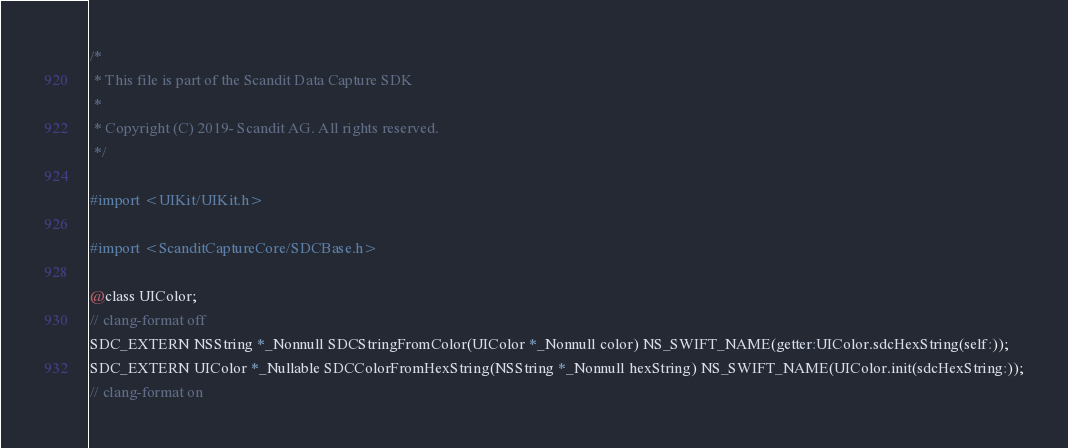<code> <loc_0><loc_0><loc_500><loc_500><_C_>/*
 * This file is part of the Scandit Data Capture SDK
 *
 * Copyright (C) 2019- Scandit AG. All rights reserved.
 */

#import <UIKit/UIKit.h>

#import <ScanditCaptureCore/SDCBase.h>

@class UIColor;
// clang-format off
SDC_EXTERN NSString *_Nonnull SDCStringFromColor(UIColor *_Nonnull color) NS_SWIFT_NAME(getter:UIColor.sdcHexString(self:));
SDC_EXTERN UIColor *_Nullable SDCColorFromHexString(NSString *_Nonnull hexString) NS_SWIFT_NAME(UIColor.init(sdcHexString:));
// clang-format on
</code> 